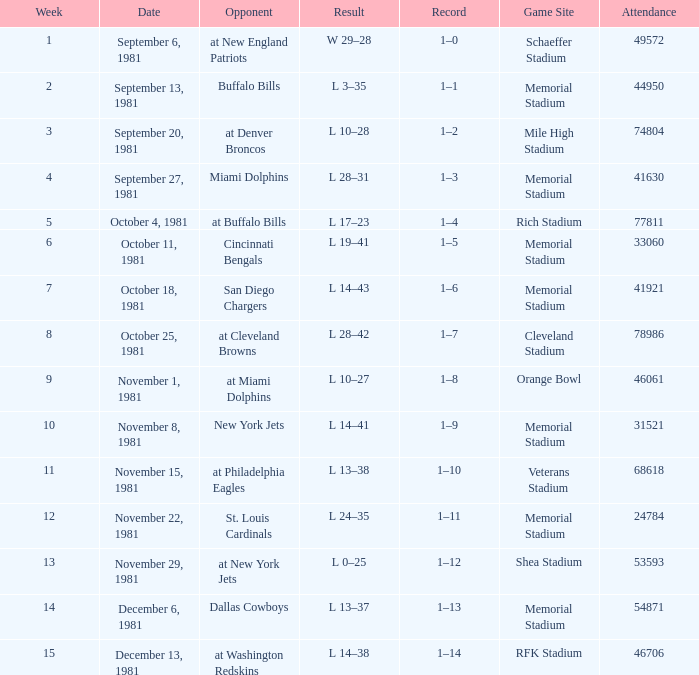When it is October 18, 1981 where is the game site? Memorial Stadium. 